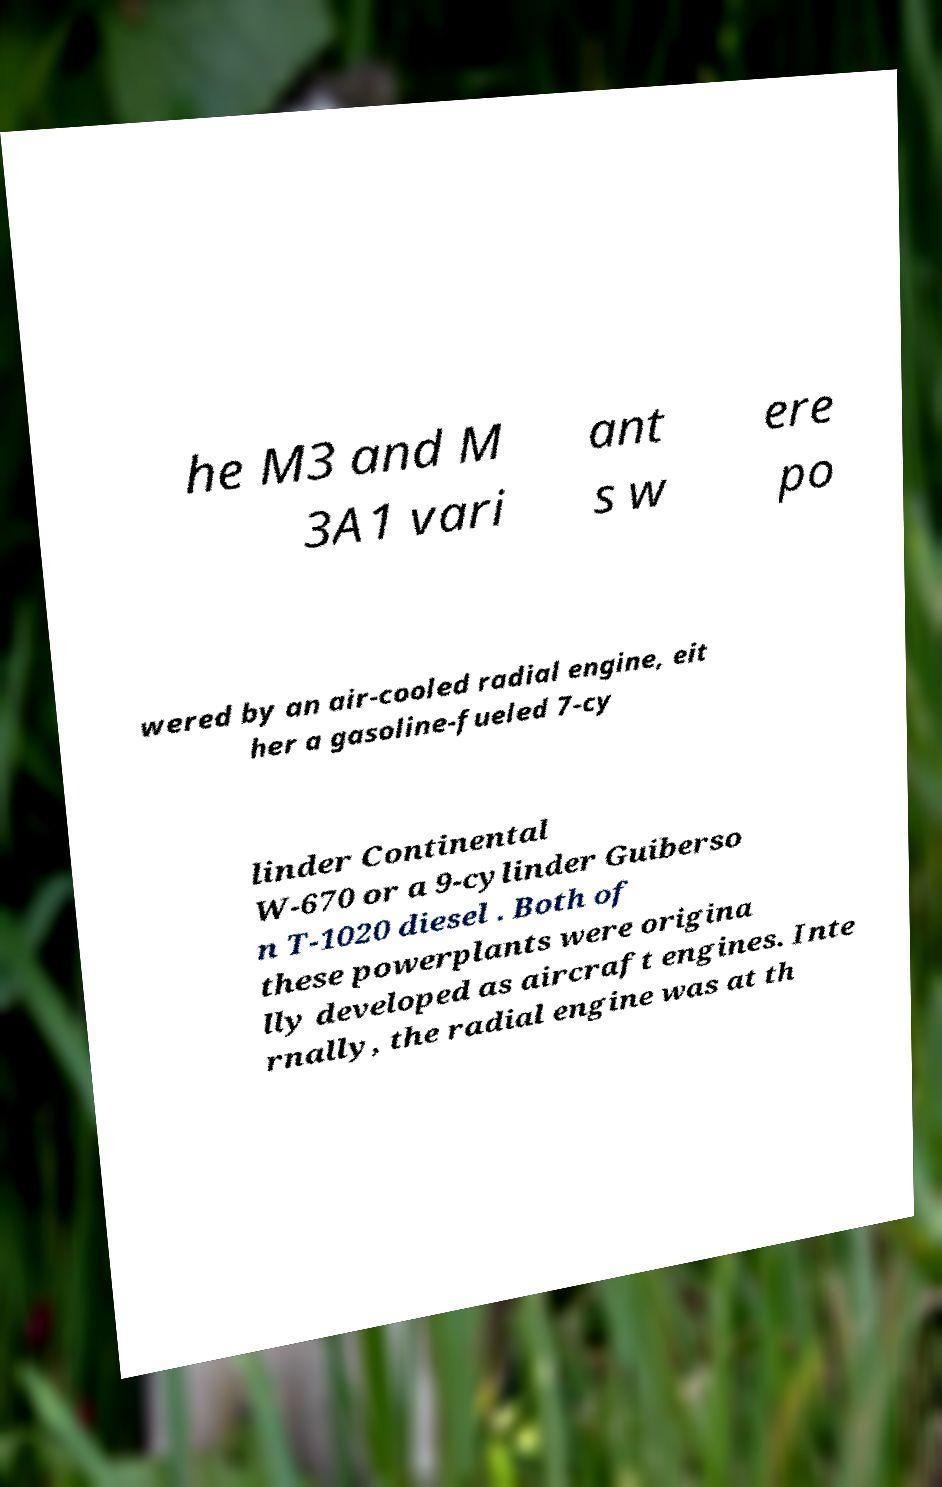I need the written content from this picture converted into text. Can you do that? he M3 and M 3A1 vari ant s w ere po wered by an air-cooled radial engine, eit her a gasoline-fueled 7-cy linder Continental W-670 or a 9-cylinder Guiberso n T-1020 diesel . Both of these powerplants were origina lly developed as aircraft engines. Inte rnally, the radial engine was at th 